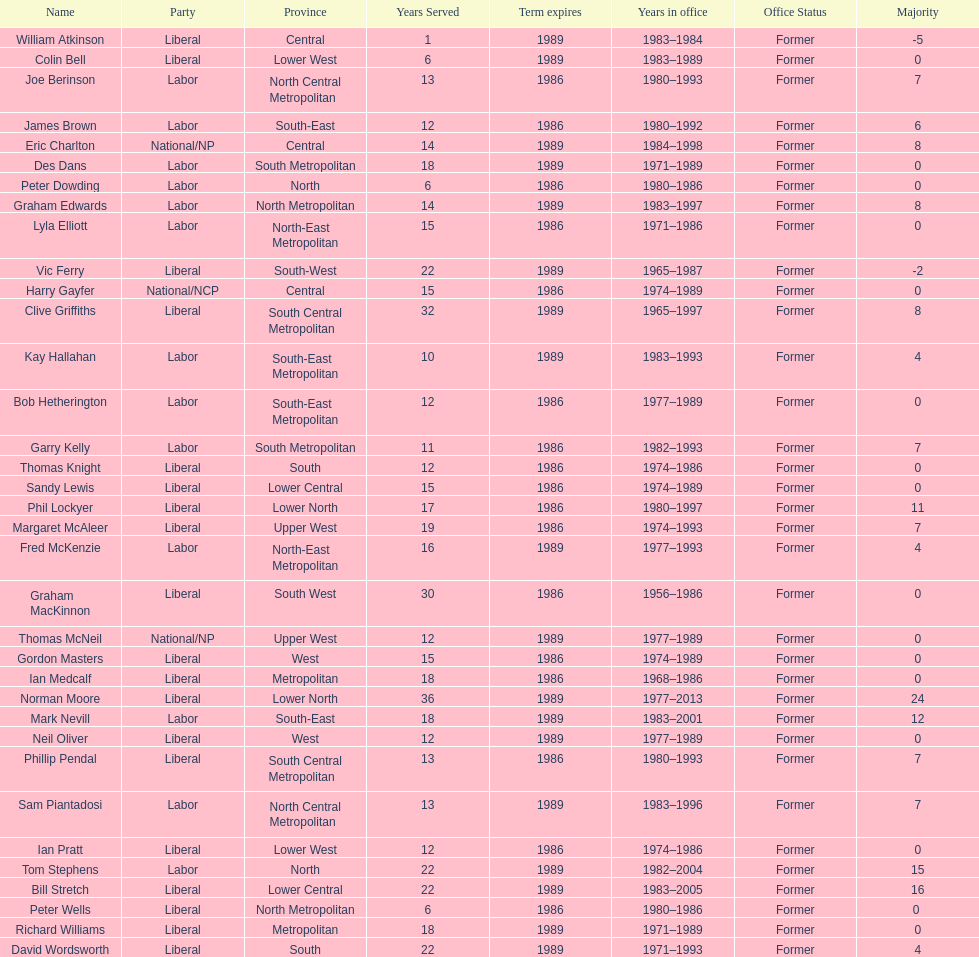Who has had the shortest term in office William Atkinson. 